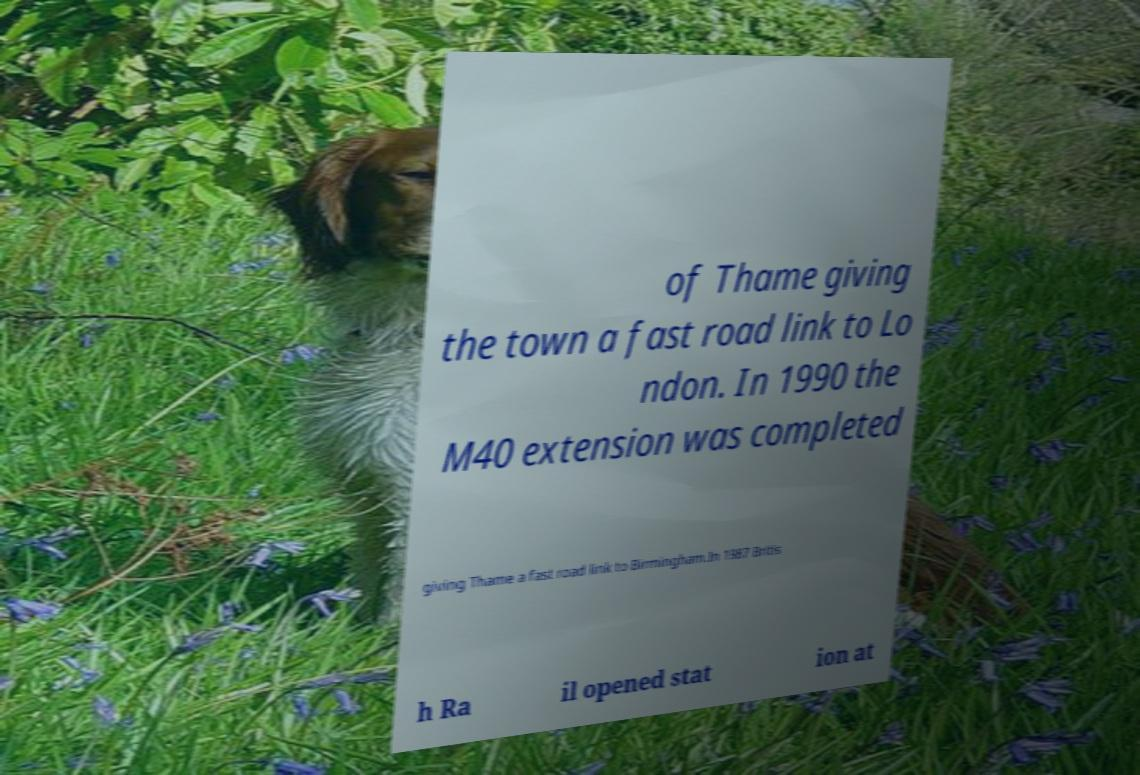For documentation purposes, I need the text within this image transcribed. Could you provide that? of Thame giving the town a fast road link to Lo ndon. In 1990 the M40 extension was completed giving Thame a fast road link to Birmingham.In 1987 Britis h Ra il opened stat ion at 